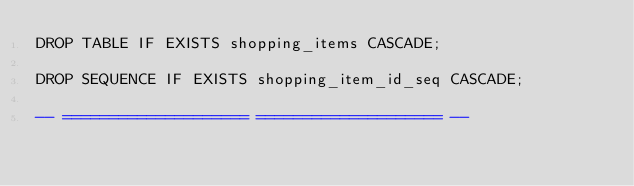Convert code to text. <code><loc_0><loc_0><loc_500><loc_500><_SQL_>DROP TABLE IF EXISTS shopping_items CASCADE;

DROP SEQUENCE IF EXISTS shopping_item_id_seq CASCADE;

-- ==================== ==================== --
</code> 